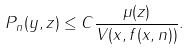Convert formula to latex. <formula><loc_0><loc_0><loc_500><loc_500>P _ { n } ( y , z ) \leq C \frac { \mu ( z ) } { V ( x , f ( x , n ) ) } .</formula> 